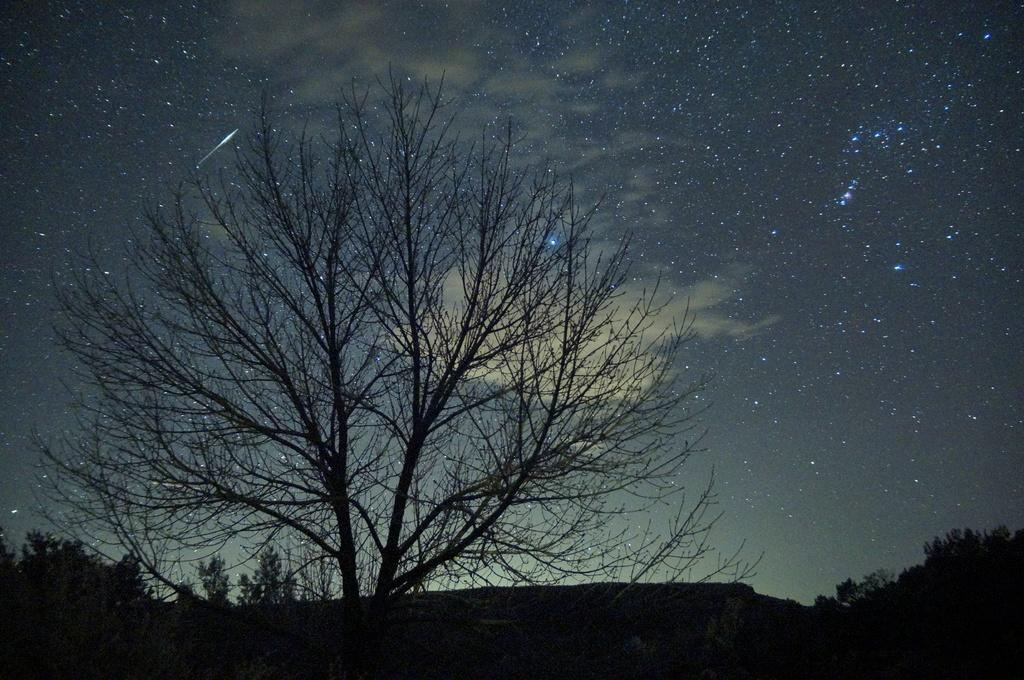What type of plant can be seen in the image? There is a tree in the image. What can be seen in the background of the image? The sky and stars are visible in the background of the image. How would you describe the lighting at the bottom of the image? The bottom of the image is dark. What part of the tree is visible at the bottom of the image? Leaves are visible at the bottom of the image. What is the rate at which the tree is growing in the image? The image does not provide information about the rate at which the tree is growing. 